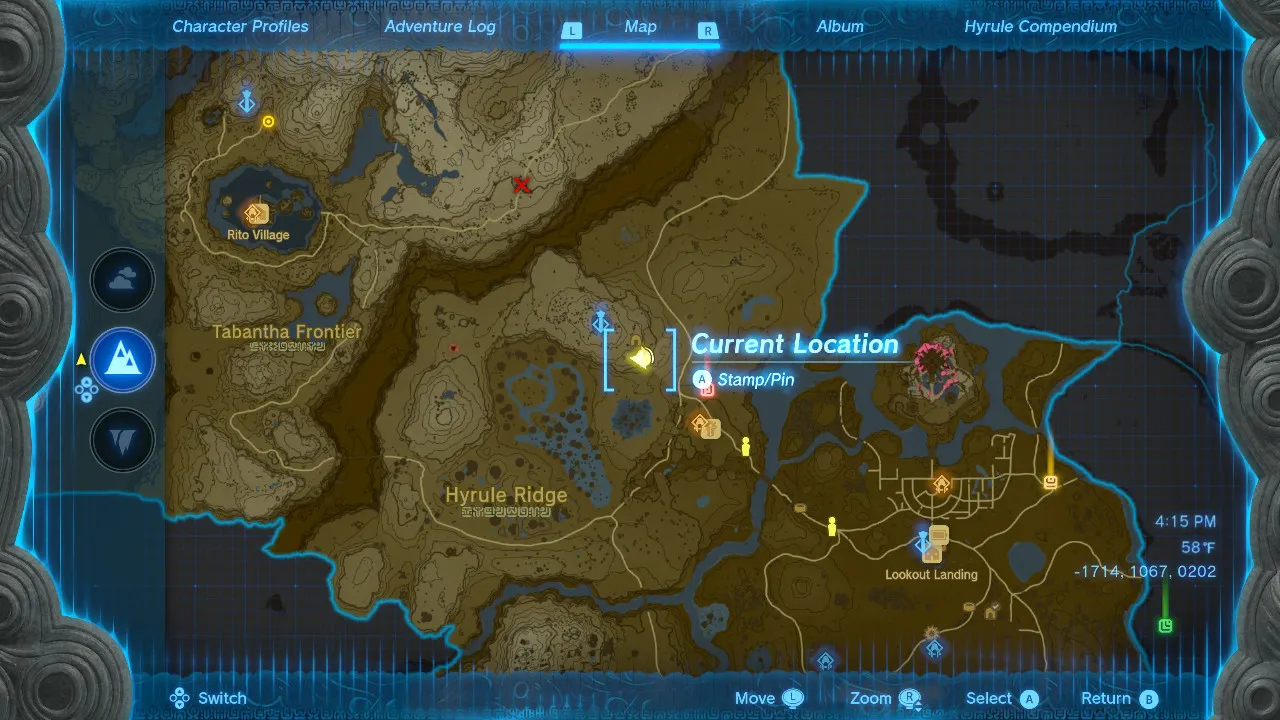What is the best way to commute from Trump Tower to the location shown in this image? The best way to commute from Trump Tower to the location shown in this image is by subway. The closest subway station to Trump Tower is 5th Avenue/59th Street, which is served by the N, R, and W trains. From there, you can take the N or R train to Times Square-42nd Street, which is located in the heart of Times Square. The walk from Times Square-42nd Street to the location shown in the image is about 5 minutes. Given my horse's location on this map, what is the quickest route to reach it? The quickest route to reach your horse is to head north, then slightly west, until you reach the road. Follow the road west until you reach the fork, then take the left path. Follow this path until you reach your horse. 